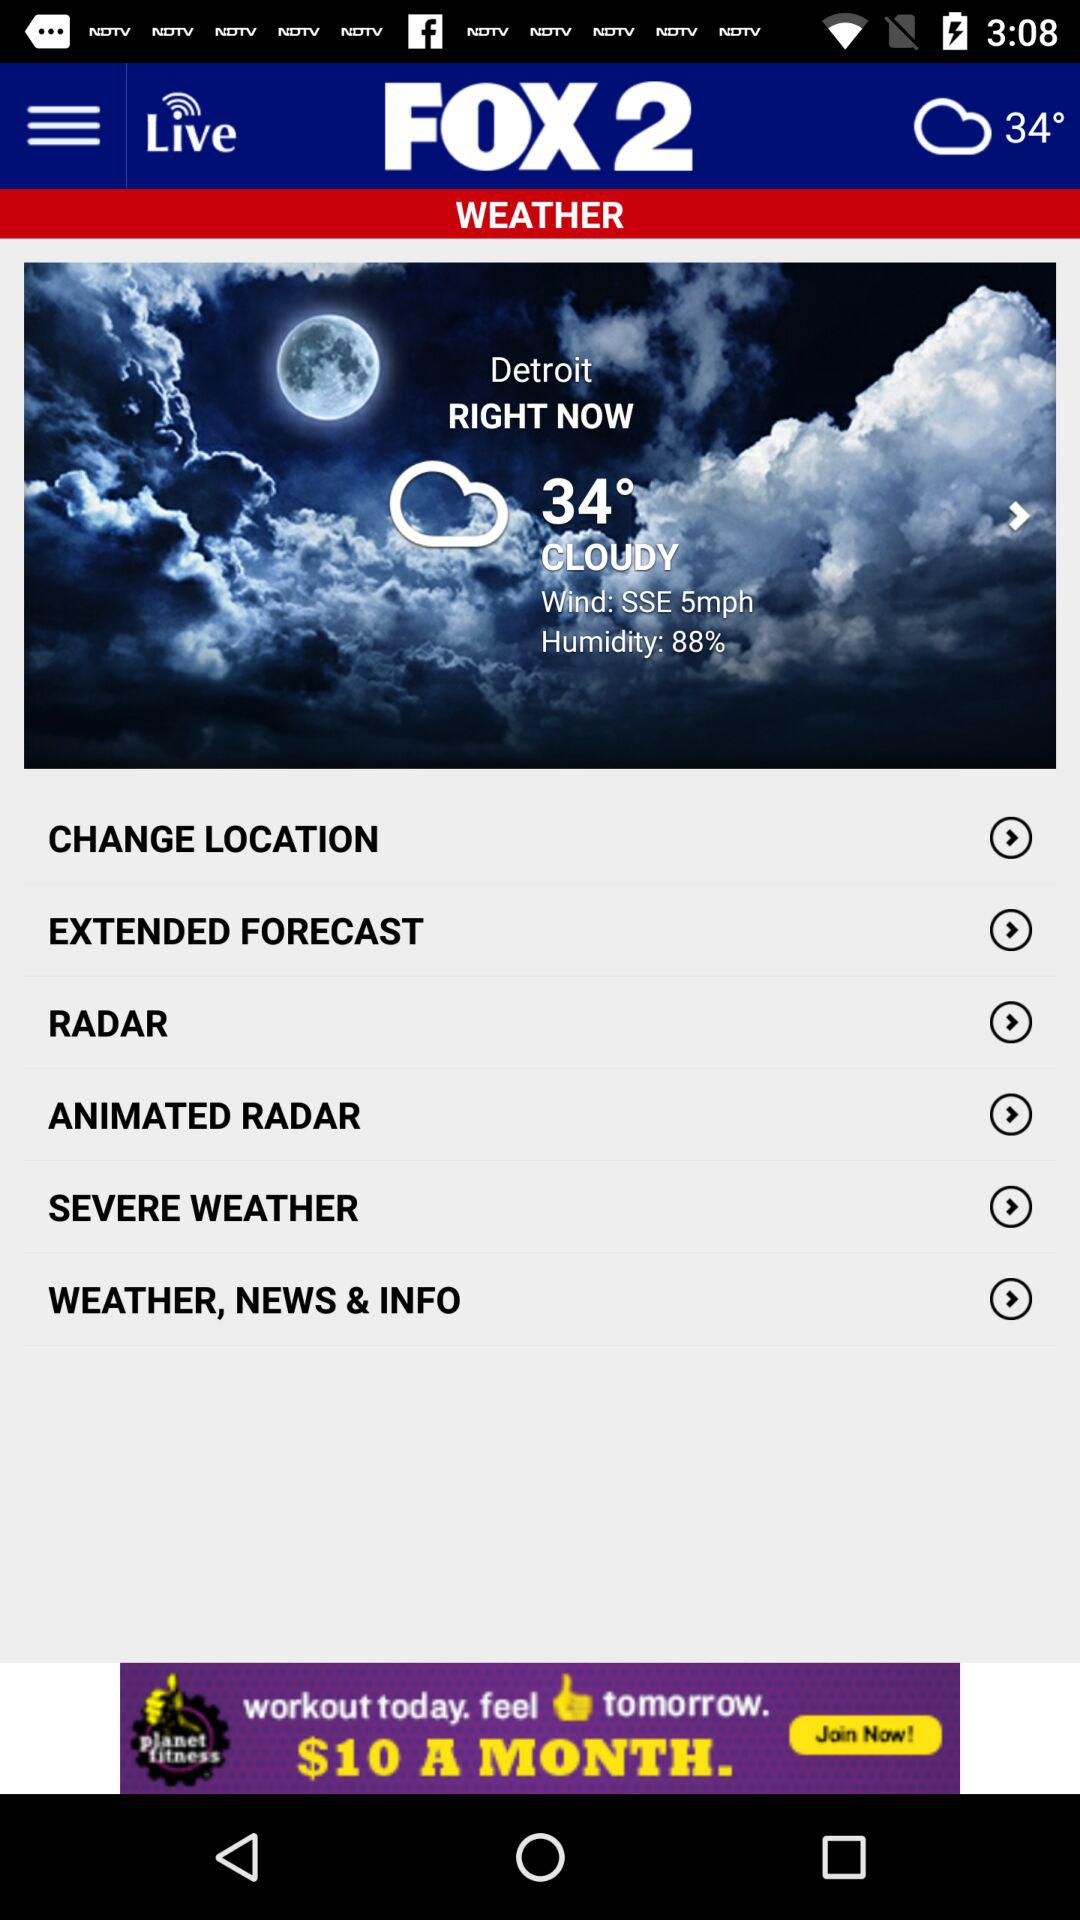What type of weather is showing up? The type of weather is cloudy. 